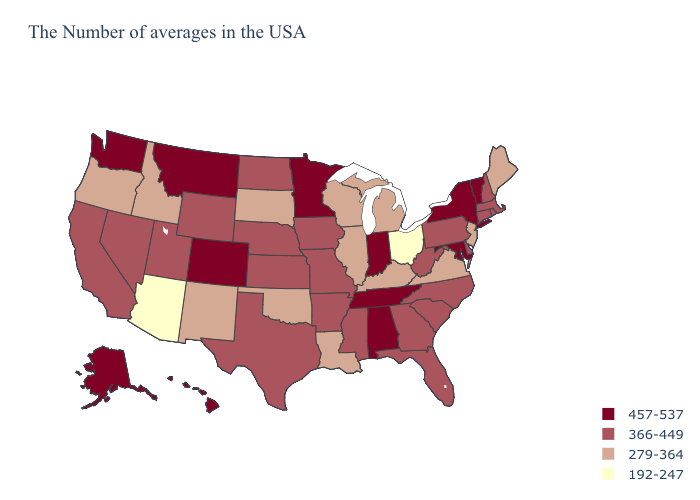Which states have the lowest value in the Northeast?
Short answer required. Maine, New Jersey. Name the states that have a value in the range 279-364?
Quick response, please. Maine, New Jersey, Virginia, Michigan, Kentucky, Wisconsin, Illinois, Louisiana, Oklahoma, South Dakota, New Mexico, Idaho, Oregon. What is the lowest value in the South?
Answer briefly. 279-364. Does Illinois have the same value as Louisiana?
Short answer required. Yes. Name the states that have a value in the range 366-449?
Keep it brief. Massachusetts, Rhode Island, New Hampshire, Connecticut, Delaware, Pennsylvania, North Carolina, South Carolina, West Virginia, Florida, Georgia, Mississippi, Missouri, Arkansas, Iowa, Kansas, Nebraska, Texas, North Dakota, Wyoming, Utah, Nevada, California. What is the value of Massachusetts?
Short answer required. 366-449. Does the map have missing data?
Answer briefly. No. What is the highest value in states that border Alabama?
Keep it brief. 457-537. Among the states that border Indiana , does Ohio have the lowest value?
Keep it brief. Yes. What is the value of Alabama?
Answer briefly. 457-537. What is the value of Arkansas?
Be succinct. 366-449. How many symbols are there in the legend?
Quick response, please. 4. How many symbols are there in the legend?
Concise answer only. 4. What is the value of North Dakota?
Answer briefly. 366-449. 